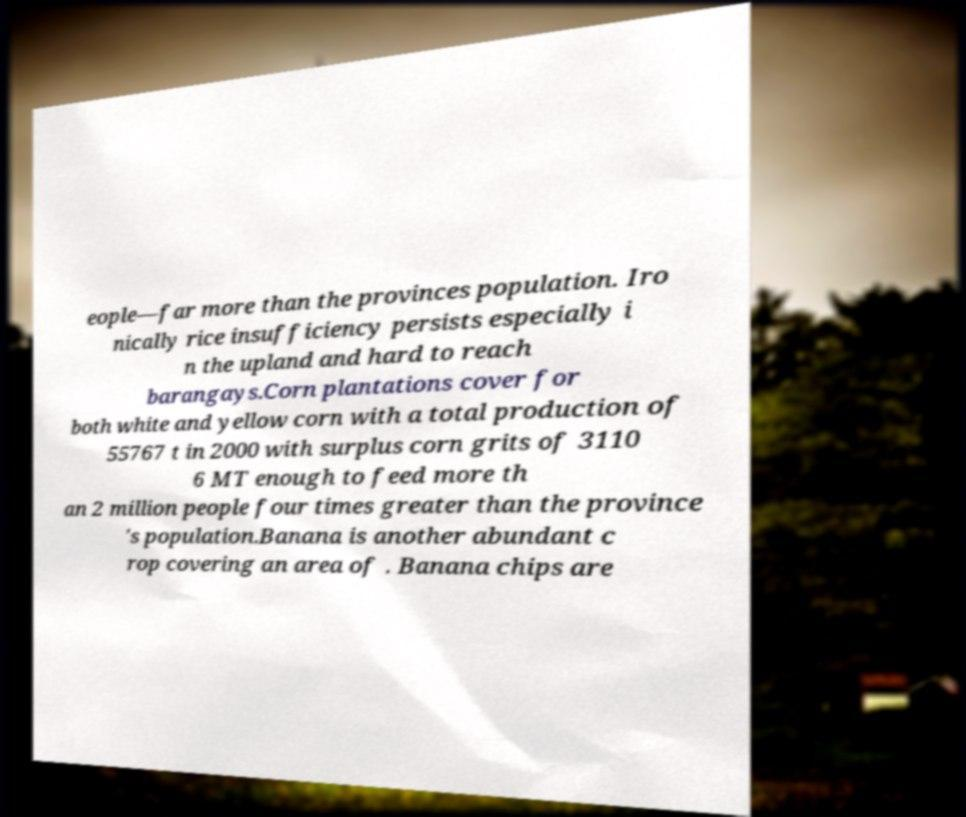For documentation purposes, I need the text within this image transcribed. Could you provide that? eople—far more than the provinces population. Iro nically rice insufficiency persists especially i n the upland and hard to reach barangays.Corn plantations cover for both white and yellow corn with a total production of 55767 t in 2000 with surplus corn grits of 3110 6 MT enough to feed more th an 2 million people four times greater than the province 's population.Banana is another abundant c rop covering an area of . Banana chips are 